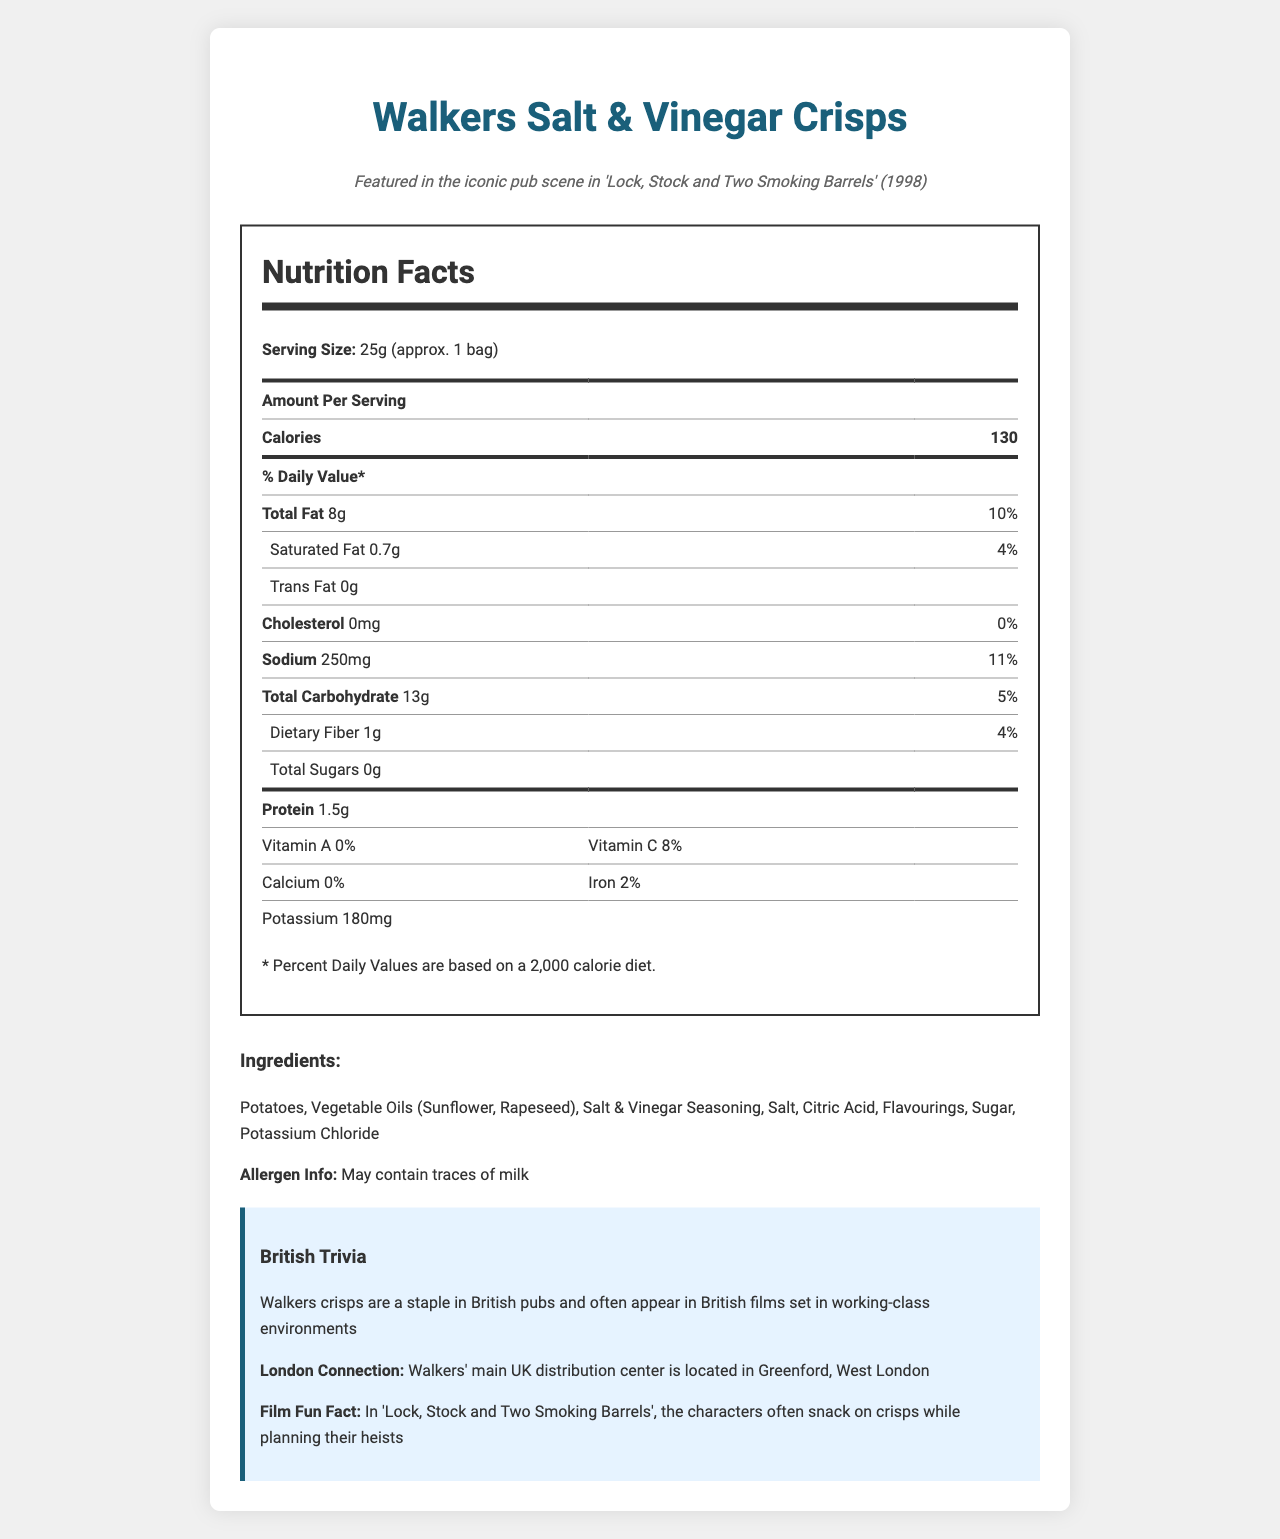what is the snack name? The document's title and the initial section clearly state the snack name is "Walkers Salt & Vinegar Crisps".
Answer: Walkers Salt & Vinegar Crisps what movie featured this snack? The movie context provided in the document mentions "Featured in the iconic pub scene in 'Lock, Stock and Two Smoking Barrels' (1998)".
Answer: Lock, Stock and Two Smoking Barrels what is the serving size for these crisps? The serving size is listed as "25g (approx. 1 bag)" in the nutrition facts section of the document.
Answer: 25g (approx. 1 bag) how many calories are in one serving? The nutrition label section lists the amount of calories per serving as 130.
Answer: 130 calories how much total fat is in one serving? The nutrition facts indicate the total fat content as 8g.
Answer: 8g how much sodium is in a serving of these crisps? The sodium content is specified as 250mg in the nutrition label.
Answer: 250mg what percentage of the daily value for saturated fat does one serving provide? The saturated fat section shows it contributes 4% to the daily value.
Answer: 4% what ingredients are used to make these crisps? The document's ingredients section lists these compounds.
Answer: Potatoes, Vegetable Oils (Sunflower, Rapeseed), Salt & Vinegar Seasoning, Salt, Citric Acid, Flavourings, Sugar, Potassium Chloride does this snack contain any allergens? The allergen info states that the crisps "May contain traces of milk".
Answer: May contain traces of milk which nutrient contributes the highest percentage of the daily value? 
A. Sodium 
B. Total Fat 
C. Dietary Fiber 
D. Vitamin C The sodium content contributes 11% to daily value, which is the highest among all listed nutrients.
Answer: A. Sodium how much protein is in one serving? 
I. 1g 
II. 1.5g 
III. 2g The protein content is specified as 1.5g on the nutrition label.
Answer: II. 1.5g is there any trans fat in these crisps? The nutrition label indicates there is 0g trans fat.
Answer: No what is the potassium content in one serving? The nutrition facts indicate the potassium content as 180mg.
Answer: 180mg true or false: these crisps provide some vitamin A. The vitamin A content is listed as 0%, indicating they do not provide any vitamin A.
Answer: False summarize the document's main idea. The document is mainly about the nutritional breakdown of the crisps, its ingredients, allergen info, and some context and trivia related to British culture and the film.
Answer: The document provides detailed nutritional information for Walkers Salt & Vinegar Crisps, including serving size, caloric content, fat, sodium, carbohydrate, and other nutrient values. It also includes the ingredient list, allergen information, and trivia about the snack’s British and London connections and its appearance in the film "Lock, Stock and Two Smoking Barrels". what is the exact launch date of Walkers Salt & Vinegar Crisps? The document does not provide any information regarding the exact launch date of Walkers Salt & Vinegar Crisps.
Answer: Not enough information 